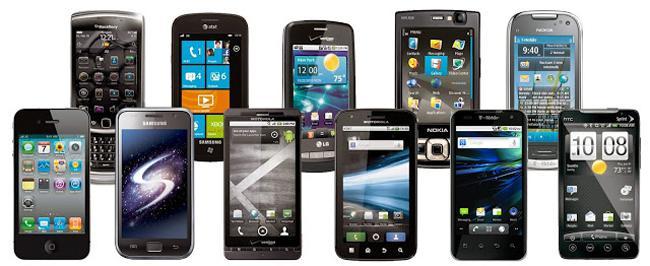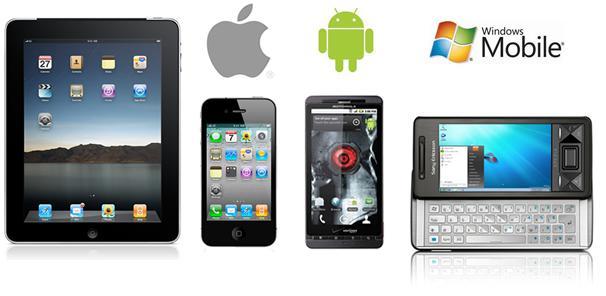The first image is the image on the left, the second image is the image on the right. Assess this claim about the two images: "The left image contains no more than two cell phones.". Correct or not? Answer yes or no. No. The first image is the image on the left, the second image is the image on the right. Given the left and right images, does the statement "A cell phone opens horizontally in the image on the right." hold true? Answer yes or no. Yes. 